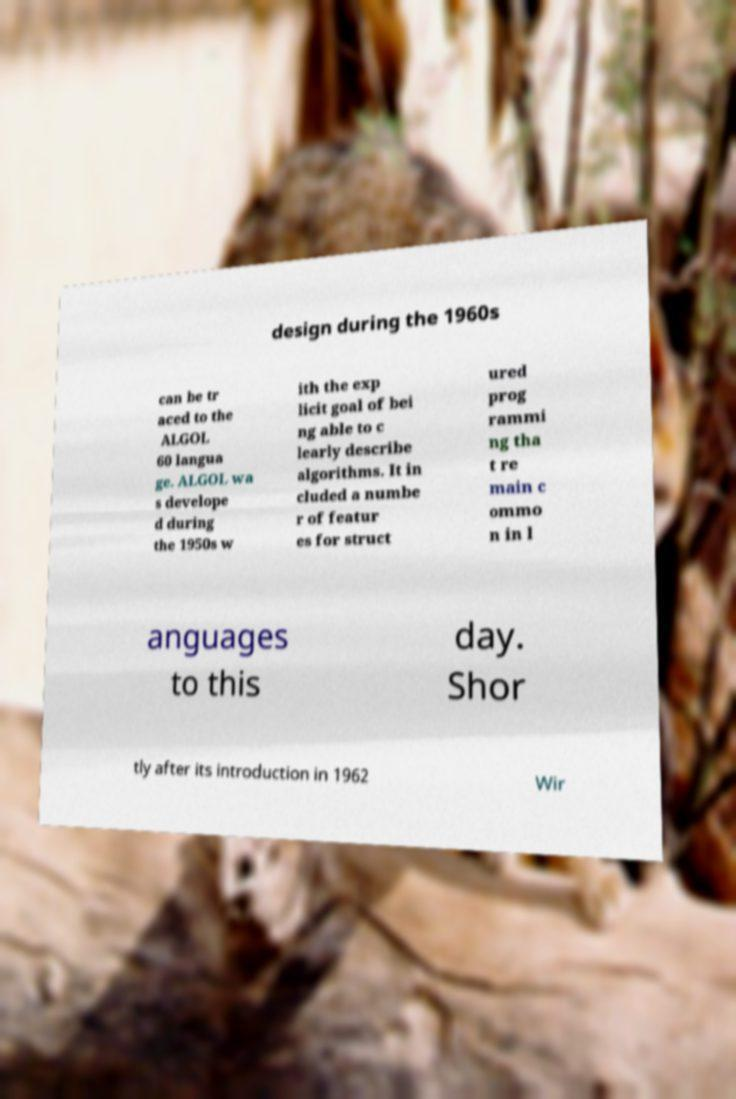For documentation purposes, I need the text within this image transcribed. Could you provide that? design during the 1960s can be tr aced to the ALGOL 60 langua ge. ALGOL wa s develope d during the 1950s w ith the exp licit goal of bei ng able to c learly describe algorithms. It in cluded a numbe r of featur es for struct ured prog rammi ng tha t re main c ommo n in l anguages to this day. Shor tly after its introduction in 1962 Wir 